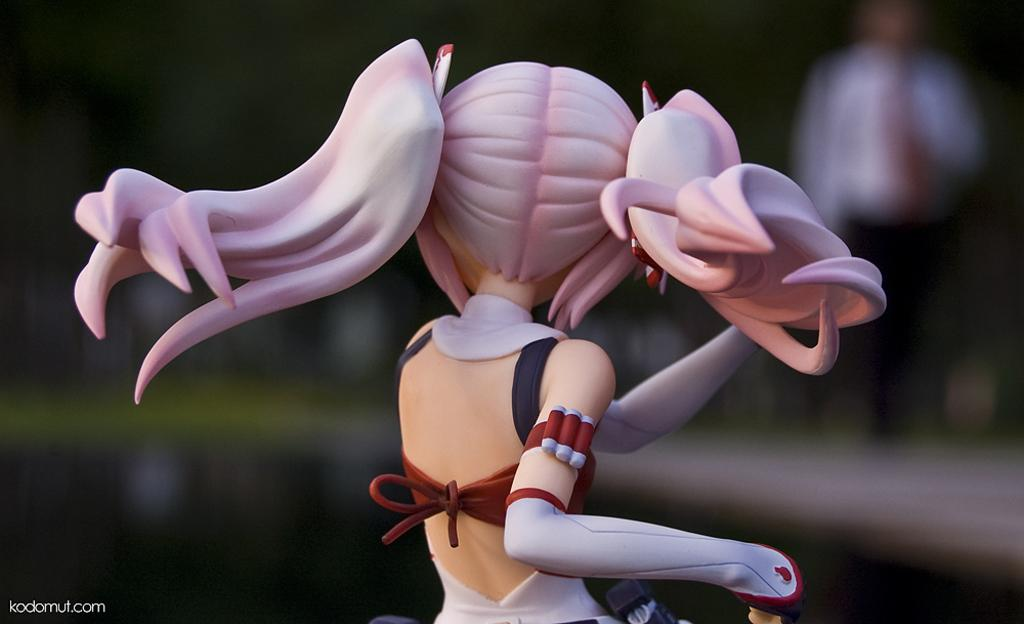What is the main object in the image? There is a toy in the image. Can you describe the toy's appearance? The toy has pink-colored hair and is wearing a maroon and white-colored dress. Who or what is in the background of the image? There is a person in the background of the image. What else can be seen in the background of the image? There are blurry objects in the background of the image. What type of flag is being raised by the toy in the image? There is no flag present in the image, and the toy is not raising anything. 